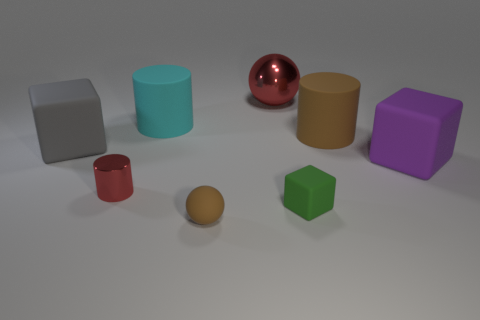There is a big thing that is to the left of the red object that is to the left of the red object behind the gray cube; what is its material? The big object to the left of the red cup, which is to the left of another red cup positioned behind the gray cube, appears to have a matte purple finish, suggesting that it might be made of a solid plastic material. 